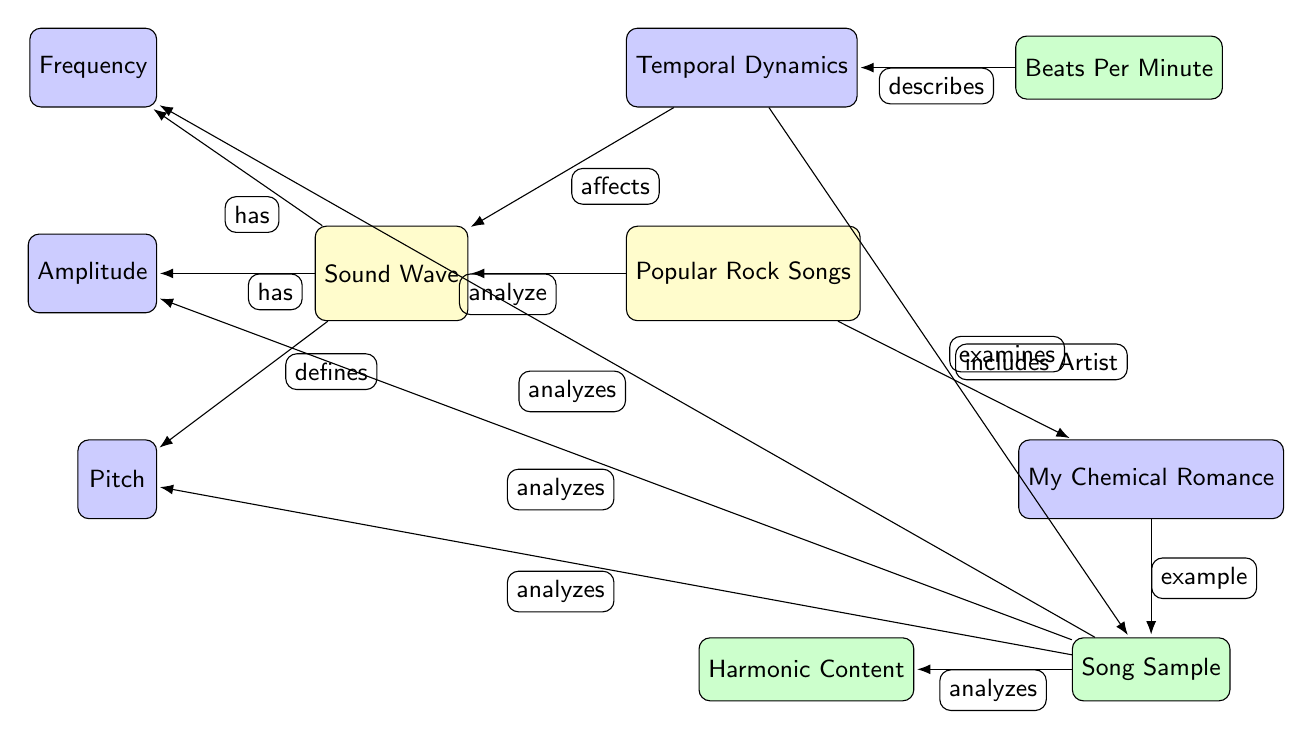What is the main subject of the diagram? The main subject is clearly labeled as "Sound Wave" at the center of the diagram.
Answer: Sound Wave How many secondary nodes are connected to the "Sound Wave" node? Counting the connections, there are four secondary nodes: Frequency, Amplitude, Pitch, and Temporal Dynamics.
Answer: Four Which artist is included in the "Popular Rock Songs"? The artist specified in the diagram is "My Chemical Romance," which is directly connected to the "Popular Rock Songs" node.
Answer: My Chemical Romance What is the relationship between "Song Sample" and "Harmonic Content"? The "Song Sample" node has a direct connection to the "Harmonic Content" node, indicating that it analyzes it.
Answer: Analyzes How does "Temporal Dynamics" affect "Sound Wave"? The diagram shows that "Temporal Dynamics" has a direct relationship with "Sound Wave," indicating it affects sound waves.
Answer: Affects What does "Beats Per Minute" describe in the context of the diagram? The connection shows that "Beats Per Minute" describes the "Temporal Dynamics," suggesting it is a measure related to rhythm and timing.
Answer: Describes How is the "Song Sample" related to its frequency analysis? The "Song Sample" analyzes many aspects, specifically including frequency, amplitude, pitch, and harmonic content, indicating a comprehensive analysis of the sound wave characteristics.
Answer: Analyzes Which node indicates the nature of the relationship between "Temporal Dynamics" and "Song Sample"? The relationship labeled "examines" represents how "Temporal Dynamics" relates to the "Song Sample."
Answer: Examines What is the defining characteristic of the "Pitch" node? The "Pitch" node is described as something that is defined by the "Sound Wave," indicating its intrinsic relationship.
Answer: Defines 